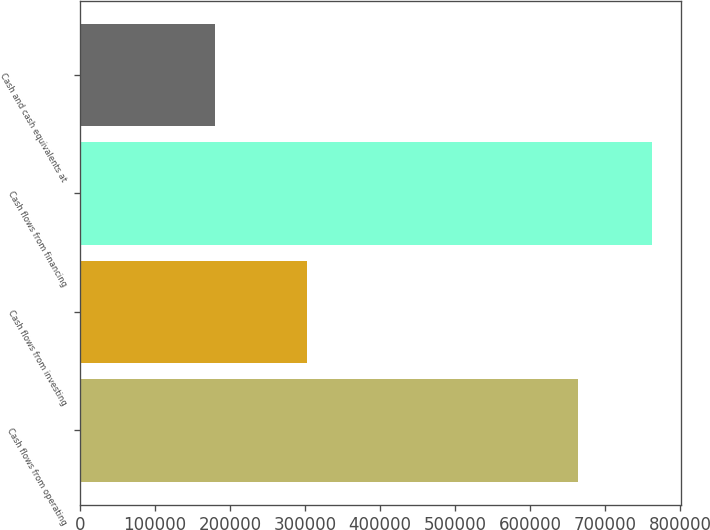Convert chart to OTSL. <chart><loc_0><loc_0><loc_500><loc_500><bar_chart><fcel>Cash flows from operating<fcel>Cash flows from investing<fcel>Cash flows from financing<fcel>Cash and cash equivalents at<nl><fcel>663514<fcel>302213<fcel>762670<fcel>179845<nl></chart> 